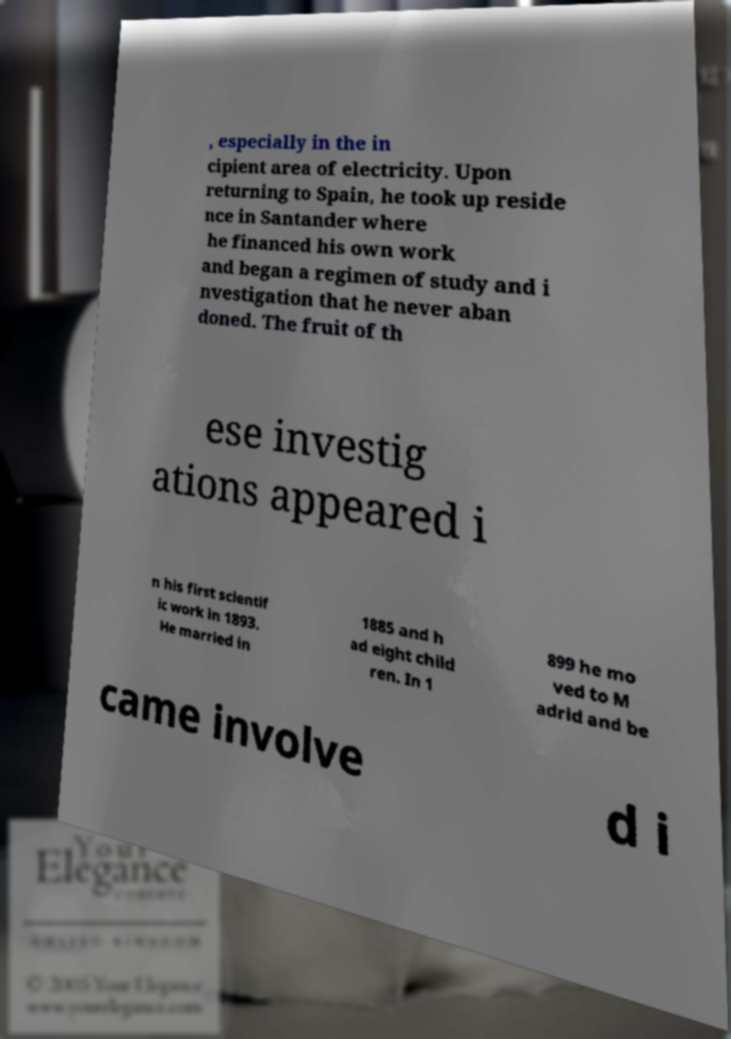I need the written content from this picture converted into text. Can you do that? , especially in the in cipient area of electricity. Upon returning to Spain, he took up reside nce in Santander where he financed his own work and began a regimen of study and i nvestigation that he never aban doned. The fruit of th ese investig ations appeared i n his first scientif ic work in 1893. He married in 1885 and h ad eight child ren. In 1 899 he mo ved to M adrid and be came involve d i 